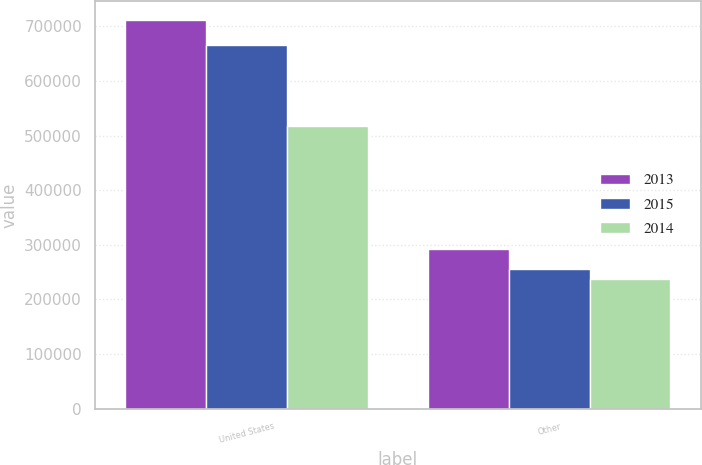Convert chart to OTSL. <chart><loc_0><loc_0><loc_500><loc_500><stacked_bar_chart><ecel><fcel>United States<fcel>Other<nl><fcel>2013<fcel>710614<fcel>291731<nl><fcel>2015<fcel>665219<fcel>256237<nl><fcel>2014<fcel>517432<fcel>236698<nl></chart> 